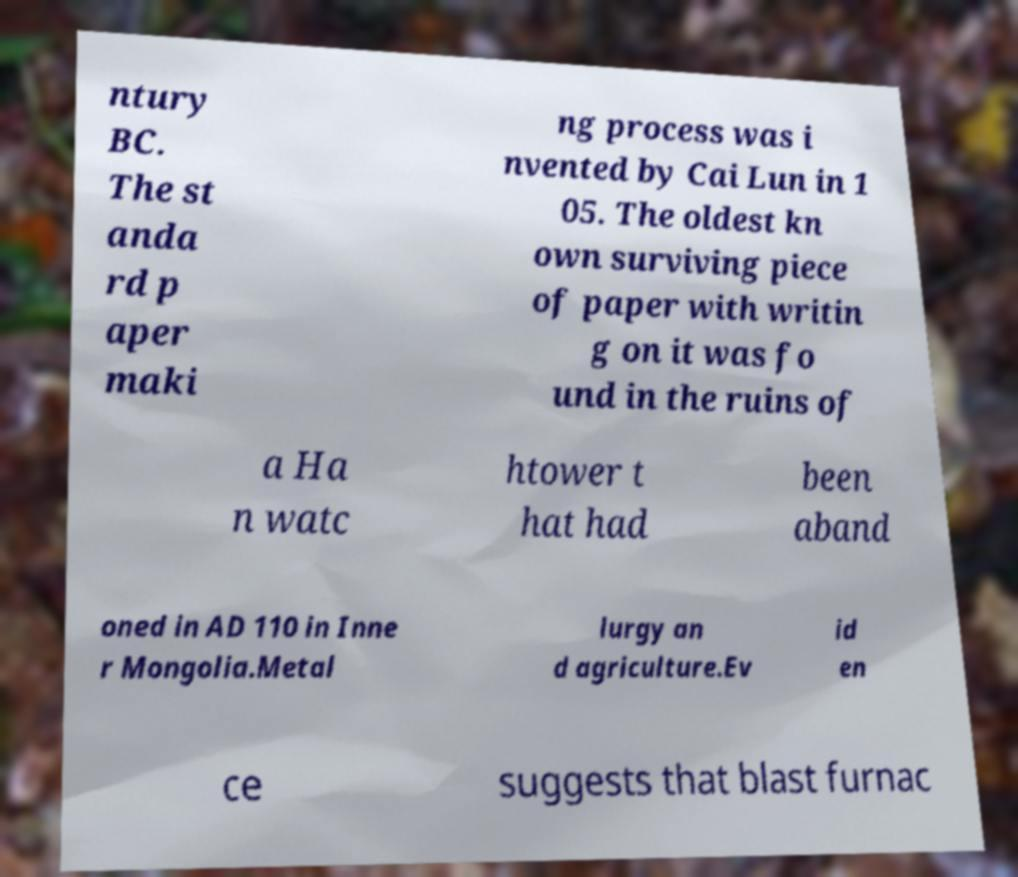Can you accurately transcribe the text from the provided image for me? ntury BC. The st anda rd p aper maki ng process was i nvented by Cai Lun in 1 05. The oldest kn own surviving piece of paper with writin g on it was fo und in the ruins of a Ha n watc htower t hat had been aband oned in AD 110 in Inne r Mongolia.Metal lurgy an d agriculture.Ev id en ce suggests that blast furnac 